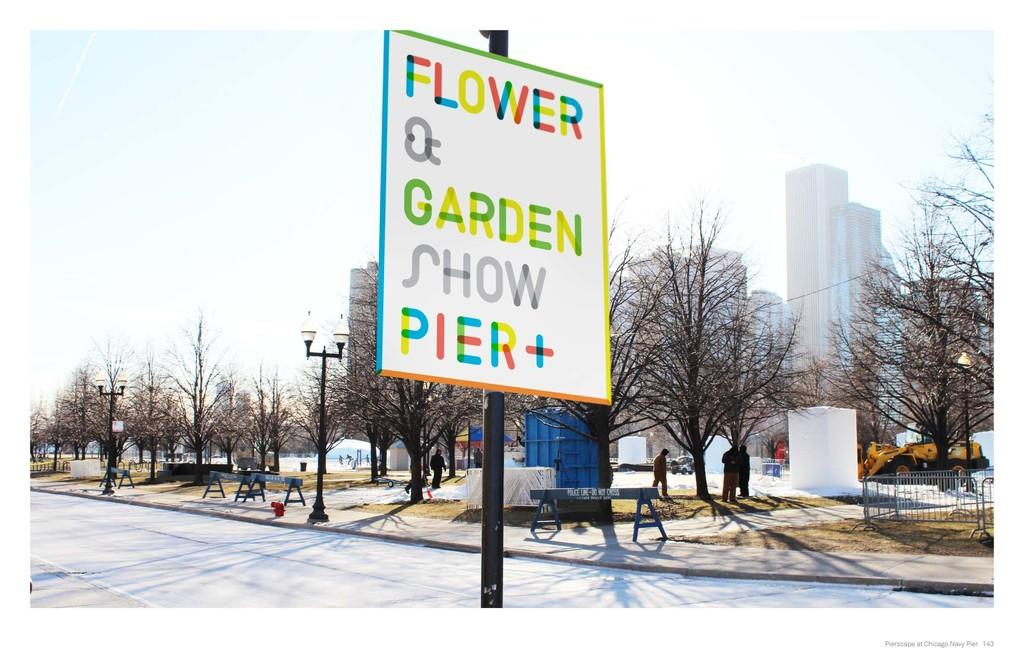<image>
Summarize the visual content of the image. A colorful sign that says Flower and Garden Show Pier Plus. 